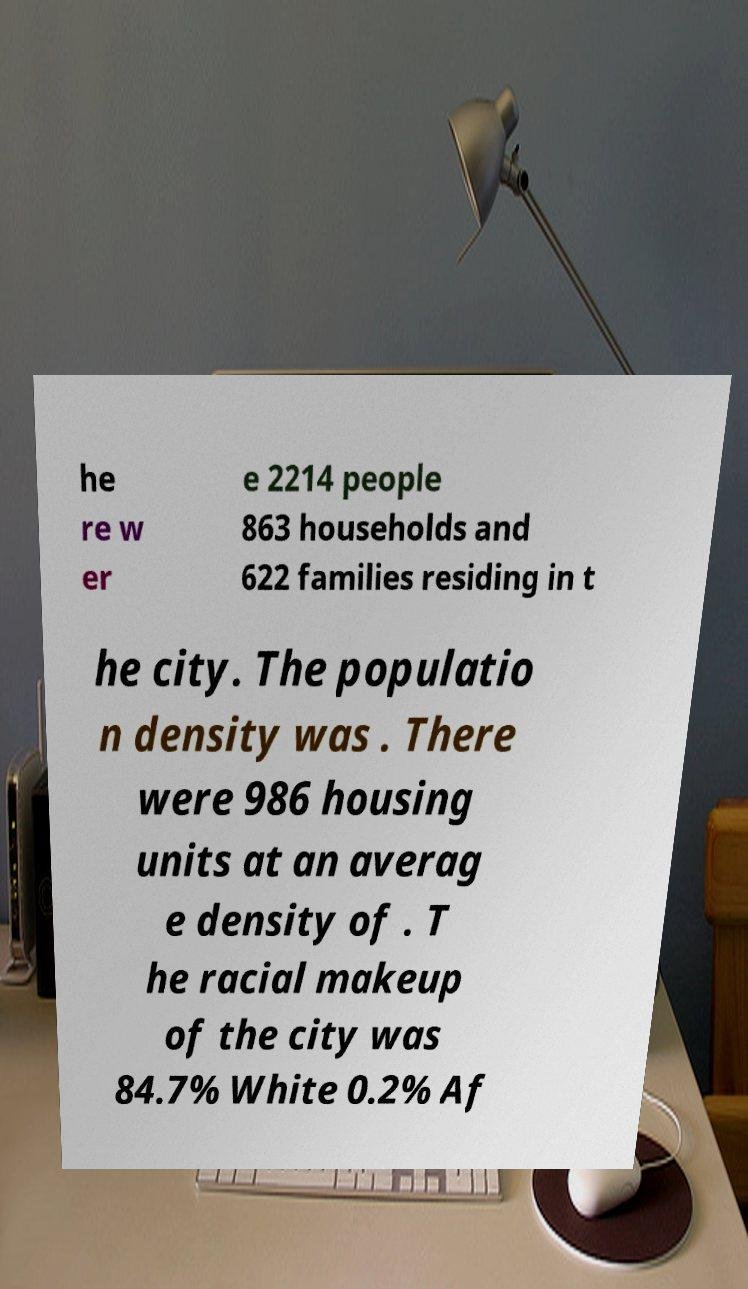For documentation purposes, I need the text within this image transcribed. Could you provide that? he re w er e 2214 people 863 households and 622 families residing in t he city. The populatio n density was . There were 986 housing units at an averag e density of . T he racial makeup of the city was 84.7% White 0.2% Af 